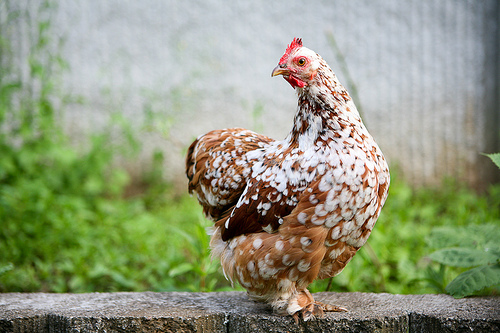<image>
Can you confirm if the chicken is to the right of the rock wall? No. The chicken is not to the right of the rock wall. The horizontal positioning shows a different relationship. 